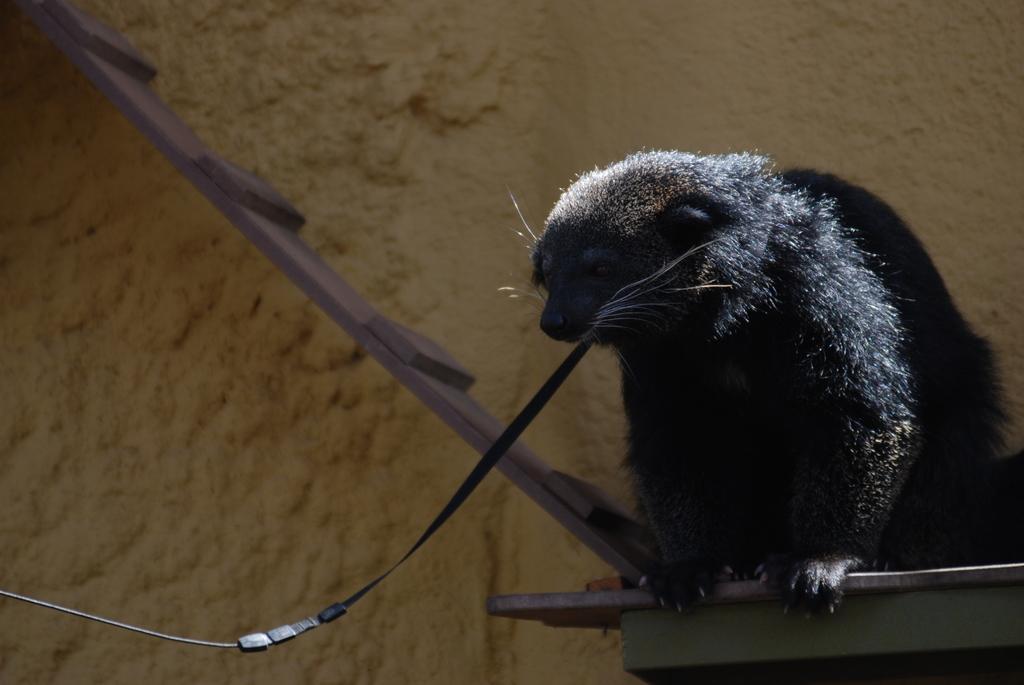Can you describe this image briefly? This image consists of an animal. It is holding a wire with its mouth. In the background, we can see a wall and a wooden plank. 